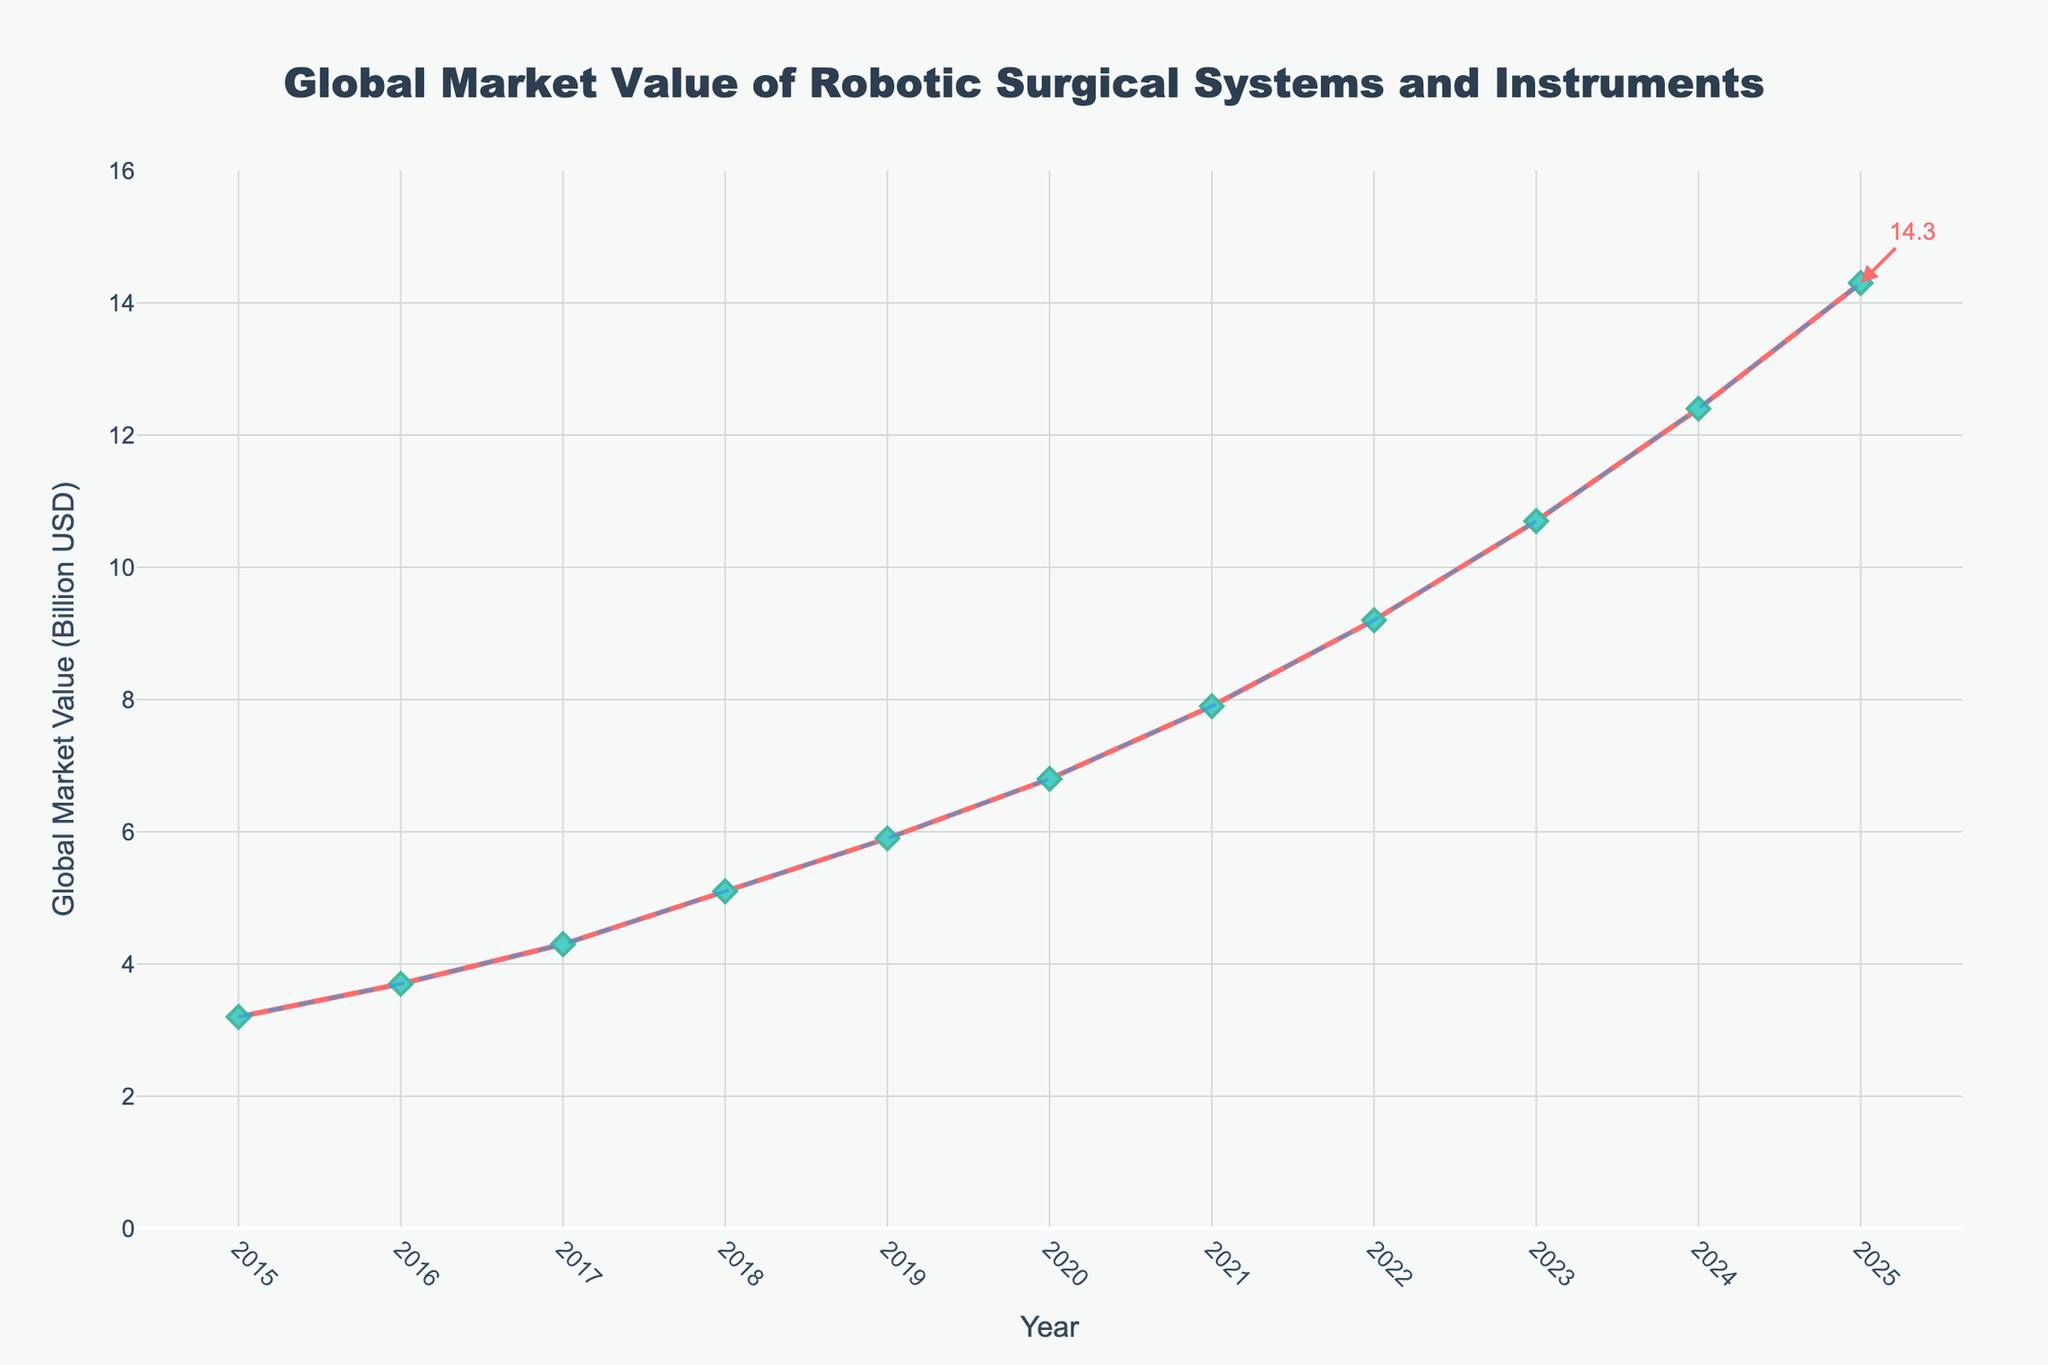What is the global market value of robotic surgical systems and instruments in 2020? Look for the data point corresponding to the year 2020 on the line chart and read the y-axis value. The marker at 2020 indicates the global market value.
Answer: 6.8 Billion USD In which year did the market value of robotic surgical systems and instruments exceed 5 billion USD for the first time? Identify the year where the y-axis value first goes above 5 billion USD. By examining the plotted data points, this occurs between 2018 and 2019. The first year above 5 billion is 2018.
Answer: 2018 What is the difference in global market value between the years 2015 and 2025? Find the global market values for the years 2015 and 2025 from the chart. The values are 3.2 Billion USD and 14.3 Billion USD, respectively. Subtract the 2015 value from the 2025 value: 14.3 - 3.2 = 11.1 Billion USD.
Answer: 11.1 Billion USD What is the average annual market value from 2015 to 2020? Sum the market values for each year from 2015 to 2020, then divide by the number of years. (3.2 + 3.7 + 4.3 + 5.1 + 5.9 + 6.8) / 6 = 29 / 6 = 4.833 should be rounded to 4.83 Billion USD.
Answer: 4.83 Billion USD What year shows the largest annual increase in market value? Examine the differences between consecutive years: 
2016-2015 = 0.5, 
2017-2016 = 0.6,
2018-2017 = 0.8,
2019-2018 = 0.8,
2020-2019 = 0.9,
2021-2020 = 1.1,
2022-2021 = 1.3,
2023-2022 = 1.5,
2024-2023 = 1.7,
2025-2024 = 1.9. 
The largest annual increase is between 2024 and 2025.
Answer: 2025 Between 2018 and 2022, how much did the global market value grow in total? Identify and sum the global market values for 2018 and 2022 and calculate the difference between these values.
(9.2 - 5.1) Billion USD = 4.1 Billion USD.
Answer: 4.1 Billion USD 